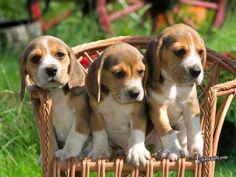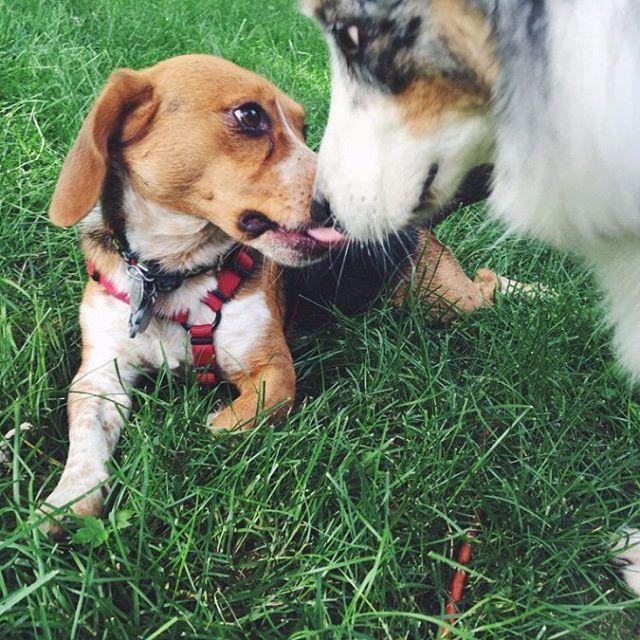The first image is the image on the left, the second image is the image on the right. Examine the images to the left and right. Is the description "The left image shows one beagle with its tongue visible" accurate? Answer yes or no. No. The first image is the image on the left, the second image is the image on the right. Assess this claim about the two images: "There is a single dog lying in the grass in the image on the right.". Correct or not? Answer yes or no. No. 